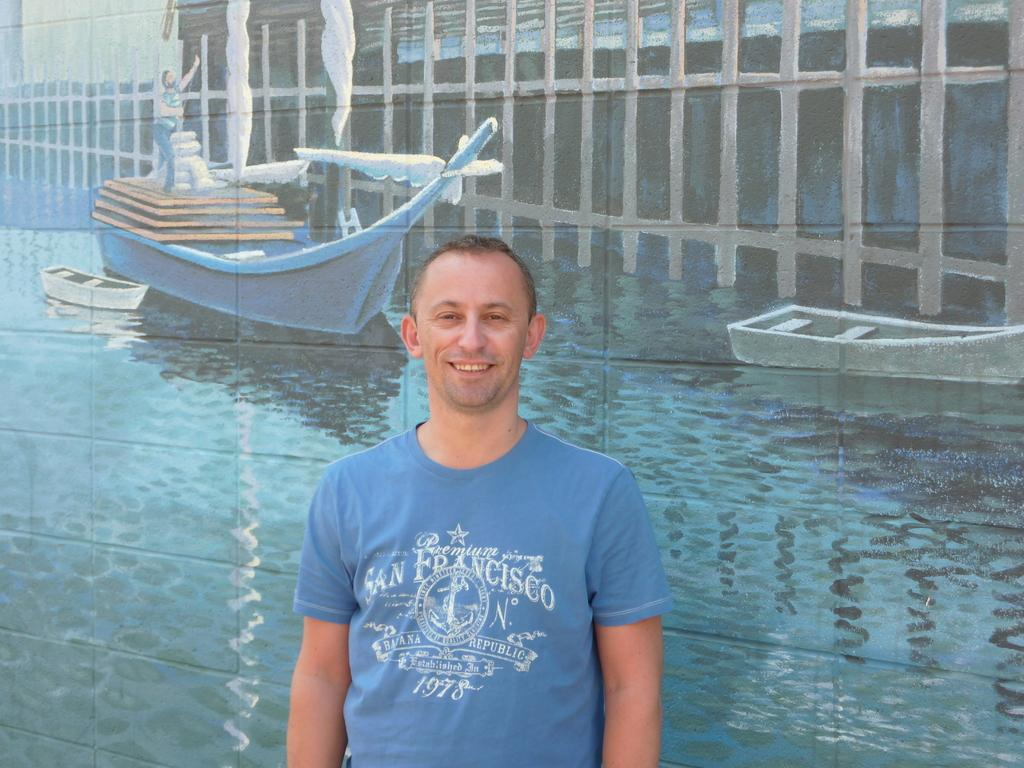Who is present in the image? There is a man in the image. What is the man wearing? The man is wearing a blue T-shirt. What expression does the man have? The man is smiling. What type of artwork is the image? The image is a painting. What type of dress can be seen hanging on the wall in the image? There is no dress present in the image; it is a painting of a man wearing a blue T-shirt. 